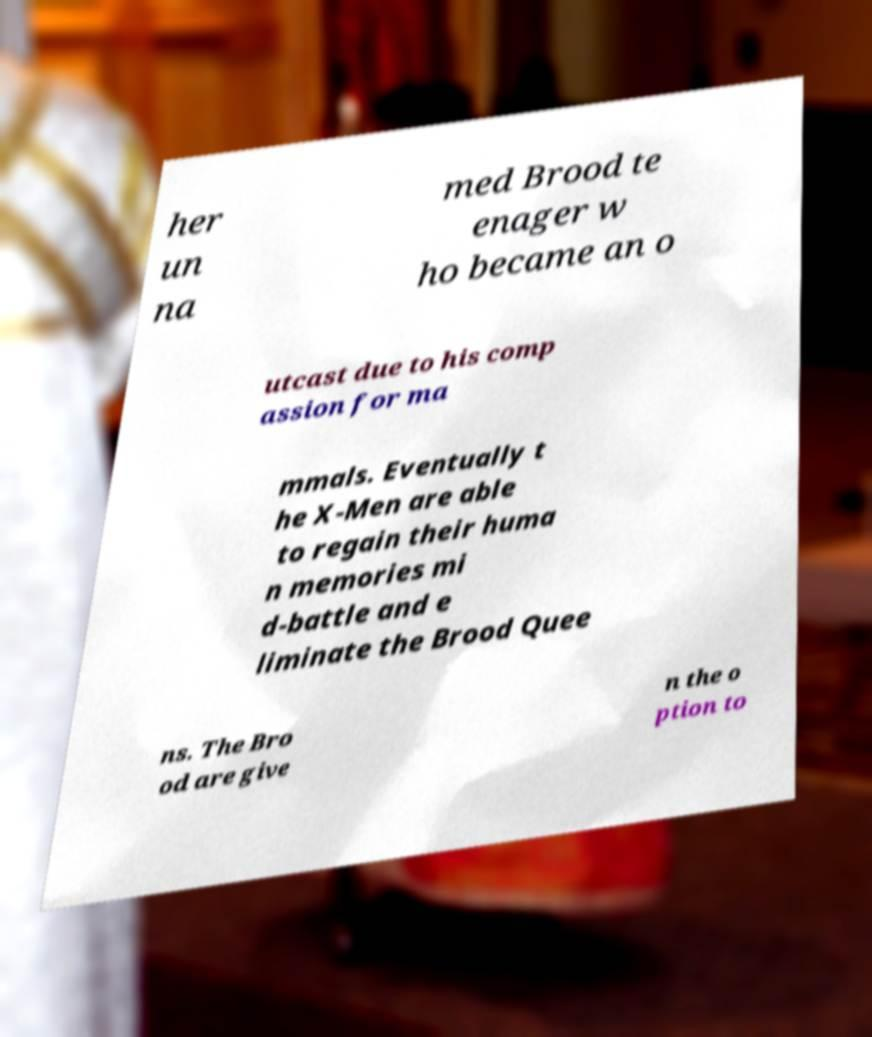Could you extract and type out the text from this image? her un na med Brood te enager w ho became an o utcast due to his comp assion for ma mmals. Eventually t he X-Men are able to regain their huma n memories mi d-battle and e liminate the Brood Quee ns. The Bro od are give n the o ption to 